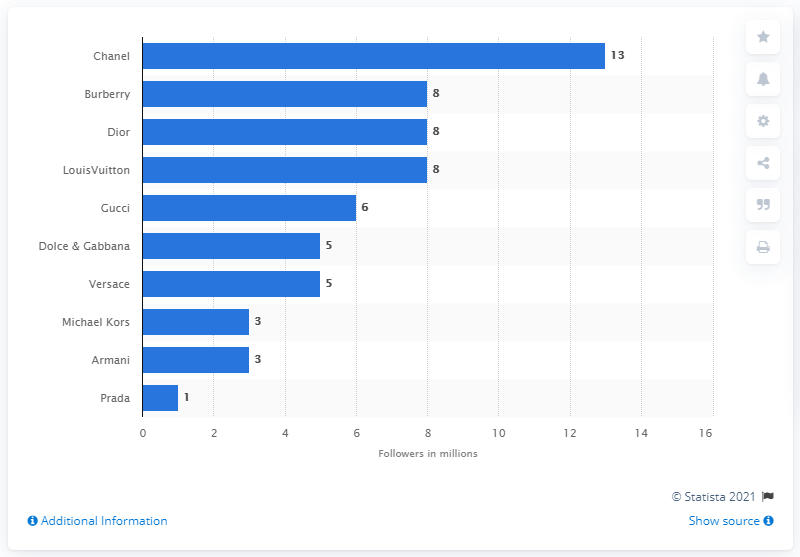Identify some key points in this picture. Chanel, a luxury French brand, had the most followers on Twitter in 2020. 